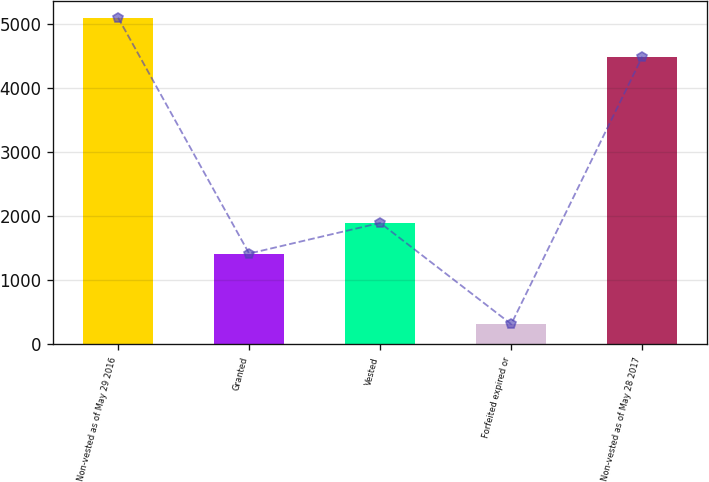Convert chart to OTSL. <chart><loc_0><loc_0><loc_500><loc_500><bar_chart><fcel>Non-vested as of May 29 2016<fcel>Granted<fcel>Vested<fcel>Forfeited expired or<fcel>Non-vested as of May 28 2017<nl><fcel>5100.4<fcel>1418.7<fcel>1896.98<fcel>317.6<fcel>4491.2<nl></chart> 